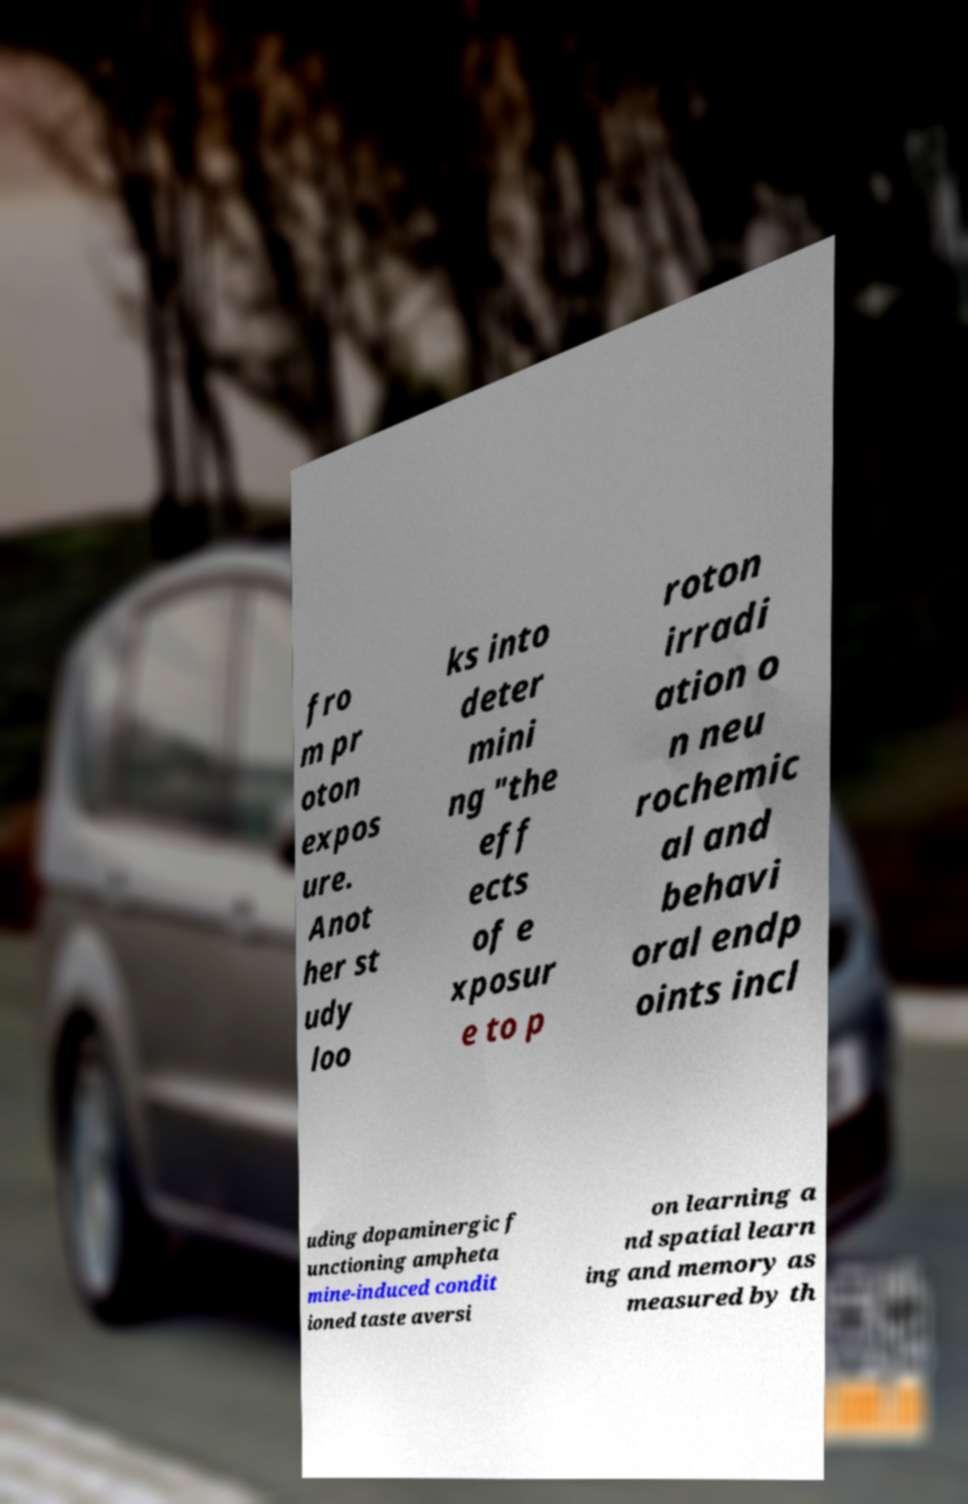For documentation purposes, I need the text within this image transcribed. Could you provide that? fro m pr oton expos ure. Anot her st udy loo ks into deter mini ng "the eff ects of e xposur e to p roton irradi ation o n neu rochemic al and behavi oral endp oints incl uding dopaminergic f unctioning ampheta mine-induced condit ioned taste aversi on learning a nd spatial learn ing and memory as measured by th 